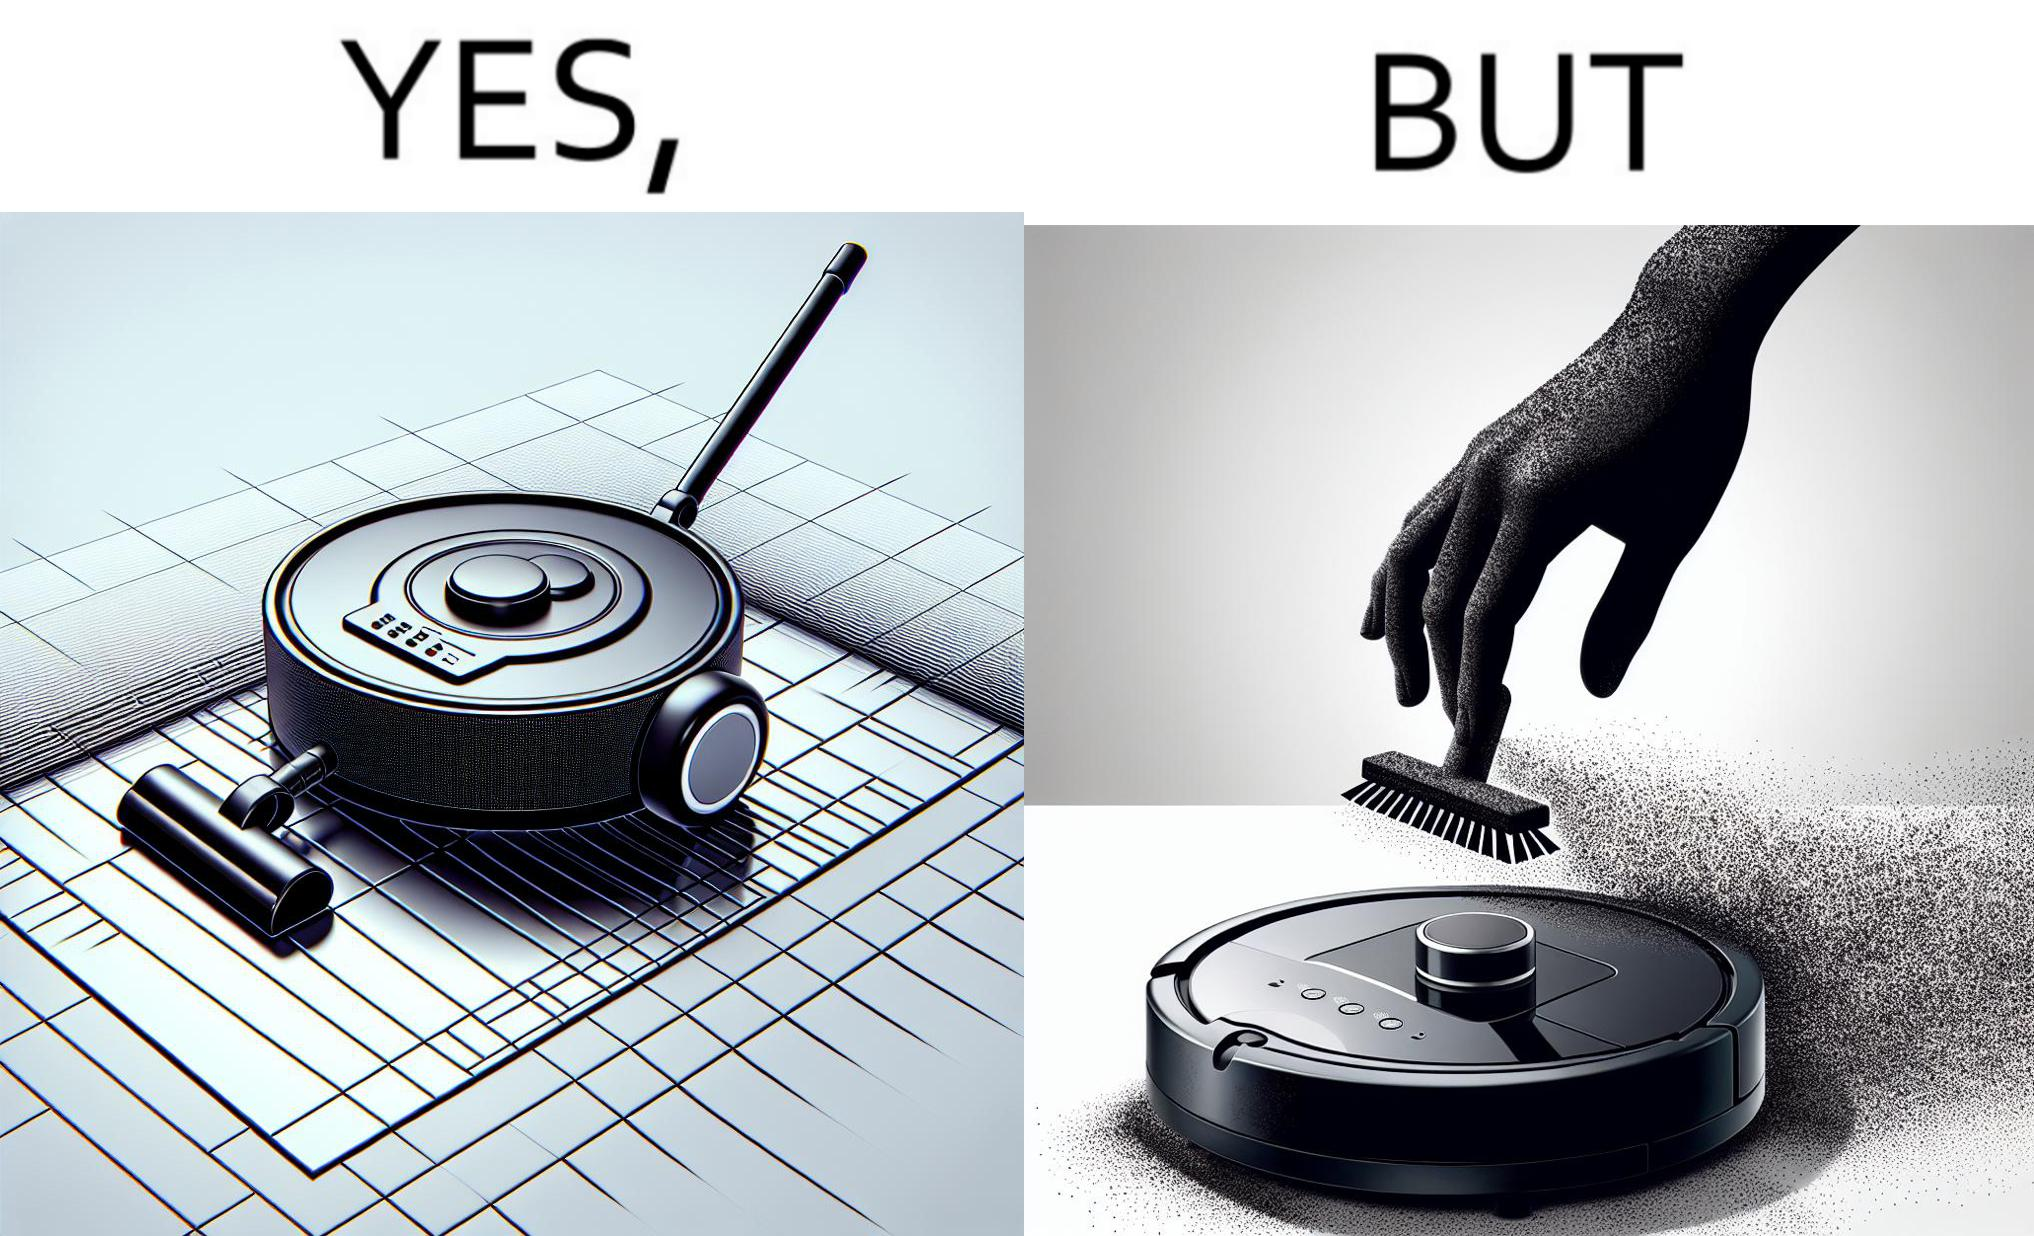What does this image depict? This is funny, because the machine while doing its job cleans everything but ends up being dirty itself. 